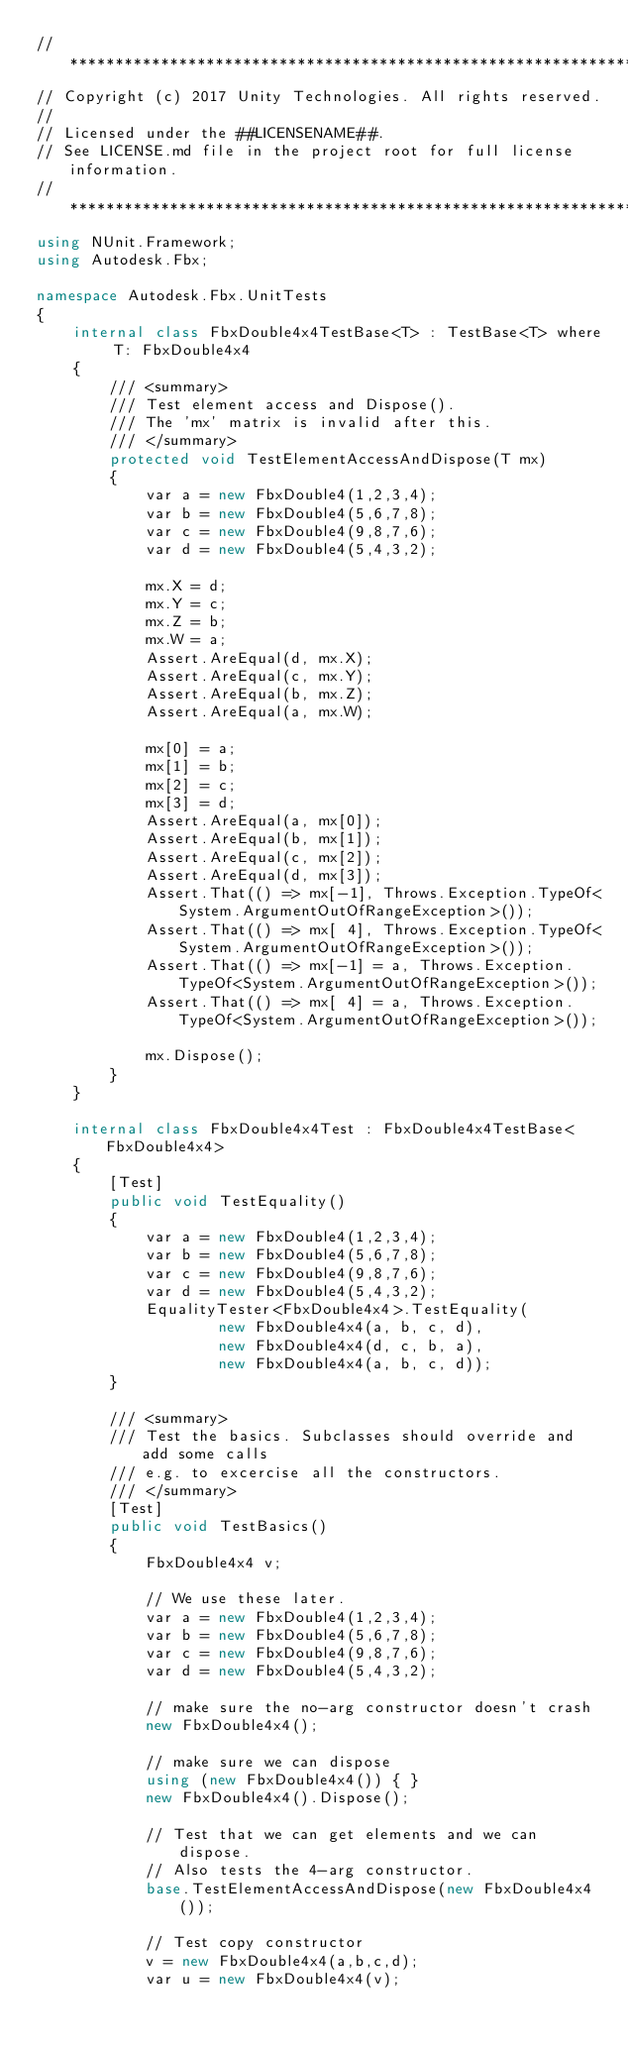Convert code to text. <code><loc_0><loc_0><loc_500><loc_500><_C#_>// ***********************************************************************
// Copyright (c) 2017 Unity Technologies. All rights reserved.
//
// Licensed under the ##LICENSENAME##.
// See LICENSE.md file in the project root for full license information.
// ***********************************************************************
using NUnit.Framework;
using Autodesk.Fbx;

namespace Autodesk.Fbx.UnitTests
{
    internal class FbxDouble4x4TestBase<T> : TestBase<T> where T: FbxDouble4x4
    {
        /// <summary>
        /// Test element access and Dispose().
        /// The 'mx' matrix is invalid after this.
        /// </summary>
        protected void TestElementAccessAndDispose(T mx)
        {
            var a = new FbxDouble4(1,2,3,4);
            var b = new FbxDouble4(5,6,7,8);
            var c = new FbxDouble4(9,8,7,6);
            var d = new FbxDouble4(5,4,3,2);

            mx.X = d;
            mx.Y = c;
            mx.Z = b;
            mx.W = a;
            Assert.AreEqual(d, mx.X);
            Assert.AreEqual(c, mx.Y);
            Assert.AreEqual(b, mx.Z);
            Assert.AreEqual(a, mx.W);

            mx[0] = a;
            mx[1] = b;
            mx[2] = c;
            mx[3] = d;
            Assert.AreEqual(a, mx[0]);
            Assert.AreEqual(b, mx[1]);
            Assert.AreEqual(c, mx[2]);
            Assert.AreEqual(d, mx[3]);
            Assert.That(() => mx[-1], Throws.Exception.TypeOf<System.ArgumentOutOfRangeException>());
            Assert.That(() => mx[ 4], Throws.Exception.TypeOf<System.ArgumentOutOfRangeException>());
            Assert.That(() => mx[-1] = a, Throws.Exception.TypeOf<System.ArgumentOutOfRangeException>());
            Assert.That(() => mx[ 4] = a, Throws.Exception.TypeOf<System.ArgumentOutOfRangeException>());

            mx.Dispose();
        }
    }

    internal class FbxDouble4x4Test : FbxDouble4x4TestBase<FbxDouble4x4>
    {
        [Test]
        public void TestEquality()
        {
            var a = new FbxDouble4(1,2,3,4);
            var b = new FbxDouble4(5,6,7,8);
            var c = new FbxDouble4(9,8,7,6);
            var d = new FbxDouble4(5,4,3,2);
            EqualityTester<FbxDouble4x4>.TestEquality(
                    new FbxDouble4x4(a, b, c, d),
                    new FbxDouble4x4(d, c, b, a),
                    new FbxDouble4x4(a, b, c, d));
        }

        /// <summary>
        /// Test the basics. Subclasses should override and add some calls
        /// e.g. to excercise all the constructors.
        /// </summary>
        [Test]
        public void TestBasics()
        {
            FbxDouble4x4 v;

            // We use these later.
            var a = new FbxDouble4(1,2,3,4);
            var b = new FbxDouble4(5,6,7,8);
            var c = new FbxDouble4(9,8,7,6);
            var d = new FbxDouble4(5,4,3,2);

            // make sure the no-arg constructor doesn't crash
            new FbxDouble4x4();

            // make sure we can dispose
            using (new FbxDouble4x4()) { }
            new FbxDouble4x4().Dispose();

            // Test that we can get elements and we can dispose.
            // Also tests the 4-arg constructor.
            base.TestElementAccessAndDispose(new FbxDouble4x4());

            // Test copy constructor
            v = new FbxDouble4x4(a,b,c,d);
            var u = new FbxDouble4x4(v);</code> 